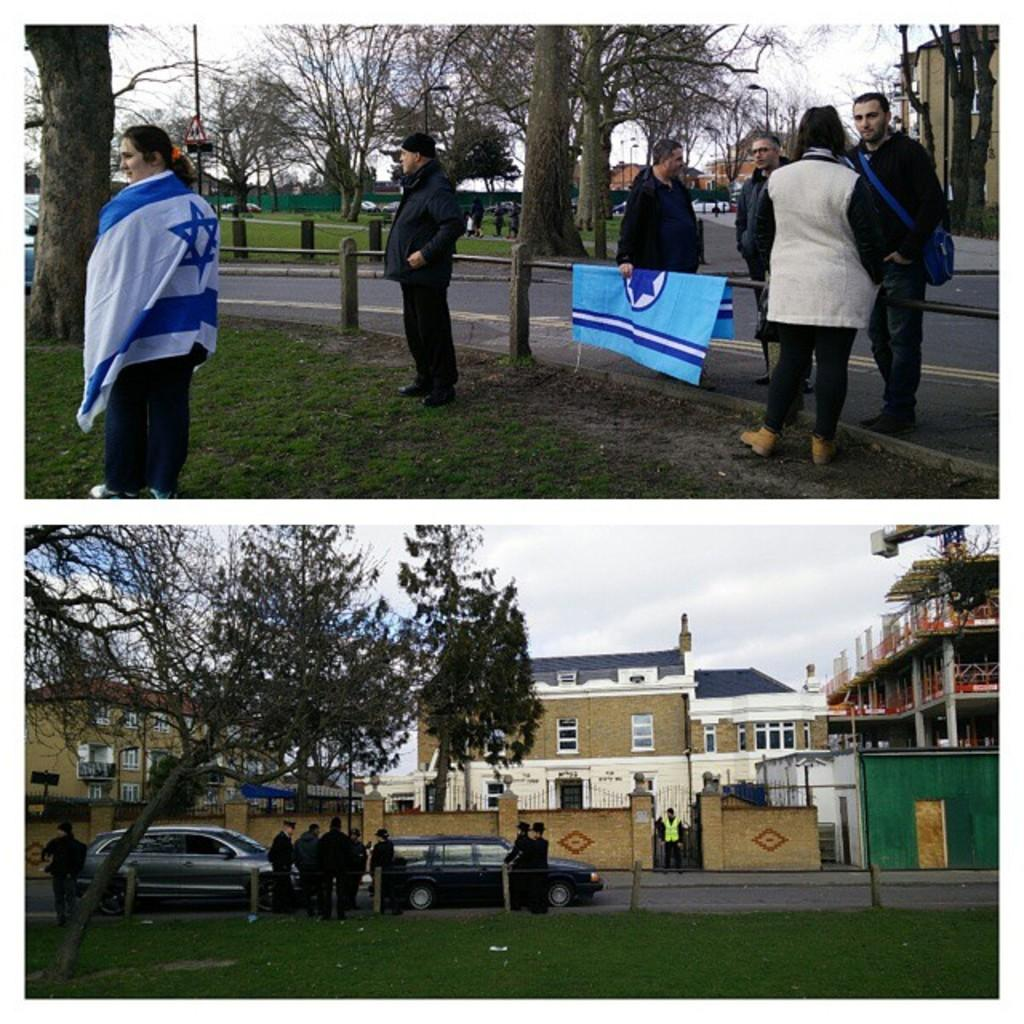What type of artwork is shown in the image? The image is a collage of multiple images. What types of vehicles can be seen in the collage? There are cars in the collage. What natural elements are present in the collage? There are trees in the collage. What man-made structures are visible in the collage? There are buildings and poles in the collage. Are there any living beings in the collage? Yes, there are people in the collage. What type of machinery is present in the collage? There is a crane in the collage. What type of signage is present in the collage? There are sign boards in the collage. What type of pest can be seen crawling on the crane in the image? There are no pests visible in the image, and no pests are crawling on the crane. 